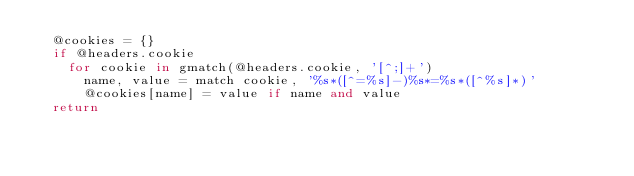Convert code to text. <code><loc_0><loc_0><loc_500><loc_500><_MoonScript_>  @cookies = {}
  if @headers.cookie
    for cookie in gmatch(@headers.cookie, '[^;]+')
      name, value = match cookie, '%s*([^=%s]-)%s*=%s*([^%s]*)'
      @cookies[name] = value if name and value
  return
</code> 